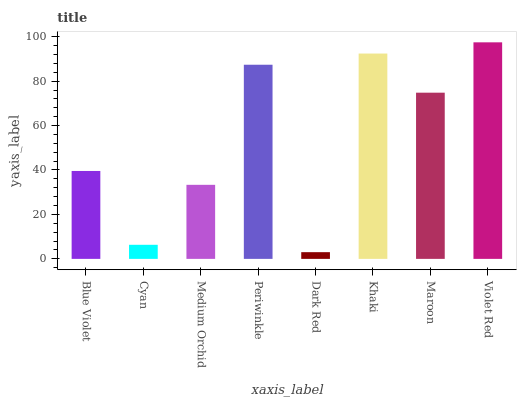Is Cyan the minimum?
Answer yes or no. No. Is Cyan the maximum?
Answer yes or no. No. Is Blue Violet greater than Cyan?
Answer yes or no. Yes. Is Cyan less than Blue Violet?
Answer yes or no. Yes. Is Cyan greater than Blue Violet?
Answer yes or no. No. Is Blue Violet less than Cyan?
Answer yes or no. No. Is Maroon the high median?
Answer yes or no. Yes. Is Blue Violet the low median?
Answer yes or no. Yes. Is Blue Violet the high median?
Answer yes or no. No. Is Khaki the low median?
Answer yes or no. No. 